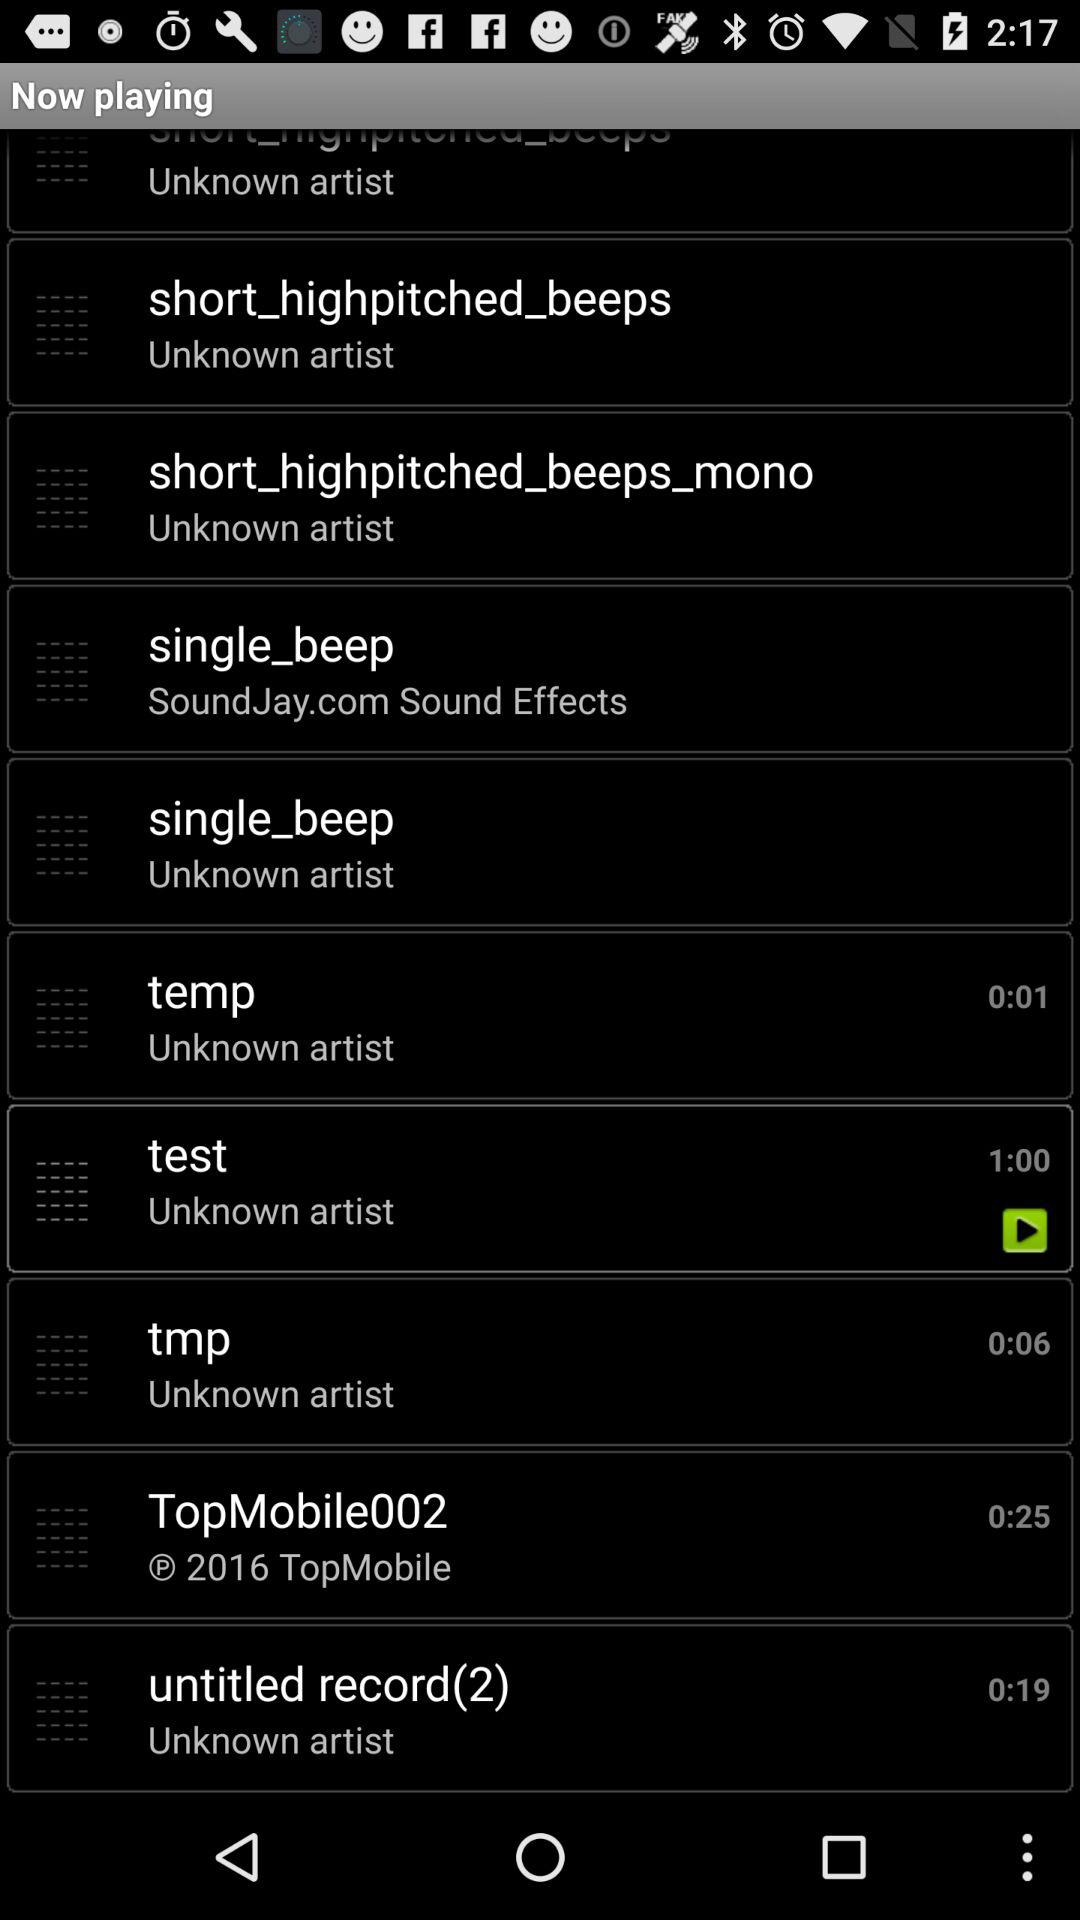What is the duration of sound tmp? The duration is 0:06. 